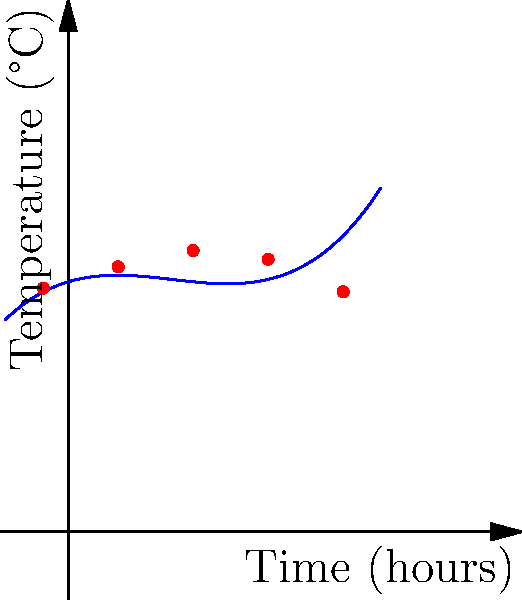Given the temperature measurements over time shown in the graph, which degree polynomial would be most appropriate to fit this data without overfitting? To determine the most appropriate degree polynomial for fitting the given temperature data, we need to consider the following steps:

1. Observe the general trend of the data points:
   The temperature starts low, increases to a peak, and then decreases again.

2. Count the number of turning points:
   There appears to be one clear turning point (maximum) in the data.

3. Apply the rule of thumb for polynomial degree:
   The degree of the polynomial should generally be one more than the number of turning points to capture the behavior without overfitting.

4. Consider the smoothness of the curve:
   The data points suggest a smooth curve rather than sharp changes.

5. Evaluate the trade-off between fit and complexity:
   A higher degree polynomial might fit the points more closely but risks overfitting and poor generalization.

Given one turning point and the smooth nature of the data, a cubic (3rd degree) polynomial would be most appropriate. It can capture the overall trend and the single turning point without introducing unnecessary complexity that could lead to overfitting.

In Python, you would typically use numpy's polyfit function to fit a 3rd degree polynomial:

```python
import numpy as np
np.polyfit(x, y, 3)
```

Where x and y are your time and temperature data, respectively.
Answer: 3rd degree (cubic) polynomial 